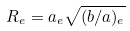Convert formula to latex. <formula><loc_0><loc_0><loc_500><loc_500>R _ { e } = a _ { e } \sqrt { ( b / a ) _ { e } }</formula> 